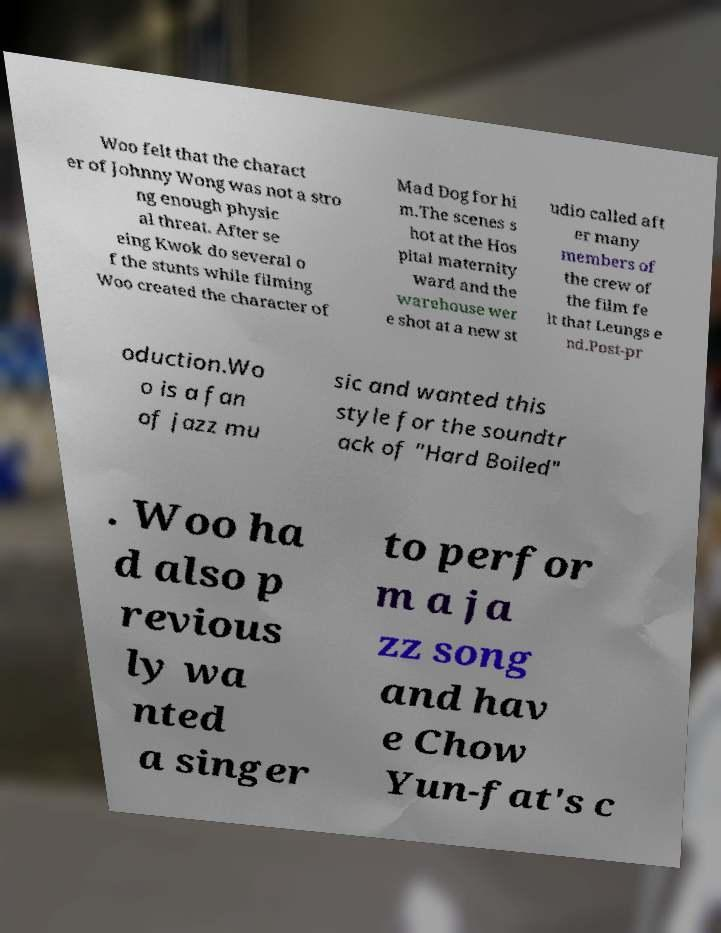Please read and relay the text visible in this image. What does it say? Woo felt that the charact er of Johnny Wong was not a stro ng enough physic al threat. After se eing Kwok do several o f the stunts while filming Woo created the character of Mad Dog for hi m.The scenes s hot at the Hos pital maternity ward and the warehouse wer e shot at a new st udio called aft er many members of the crew of the film fe lt that Leungs e nd.Post-pr oduction.Wo o is a fan of jazz mu sic and wanted this style for the soundtr ack of "Hard Boiled" . Woo ha d also p revious ly wa nted a singer to perfor m a ja zz song and hav e Chow Yun-fat's c 